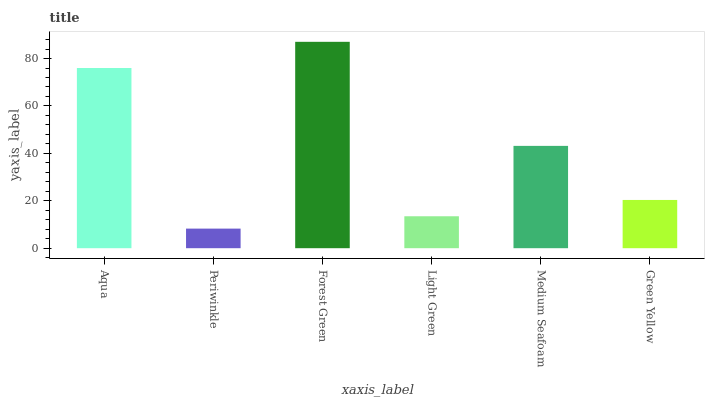Is Periwinkle the minimum?
Answer yes or no. Yes. Is Forest Green the maximum?
Answer yes or no. Yes. Is Forest Green the minimum?
Answer yes or no. No. Is Periwinkle the maximum?
Answer yes or no. No. Is Forest Green greater than Periwinkle?
Answer yes or no. Yes. Is Periwinkle less than Forest Green?
Answer yes or no. Yes. Is Periwinkle greater than Forest Green?
Answer yes or no. No. Is Forest Green less than Periwinkle?
Answer yes or no. No. Is Medium Seafoam the high median?
Answer yes or no. Yes. Is Green Yellow the low median?
Answer yes or no. Yes. Is Light Green the high median?
Answer yes or no. No. Is Forest Green the low median?
Answer yes or no. No. 